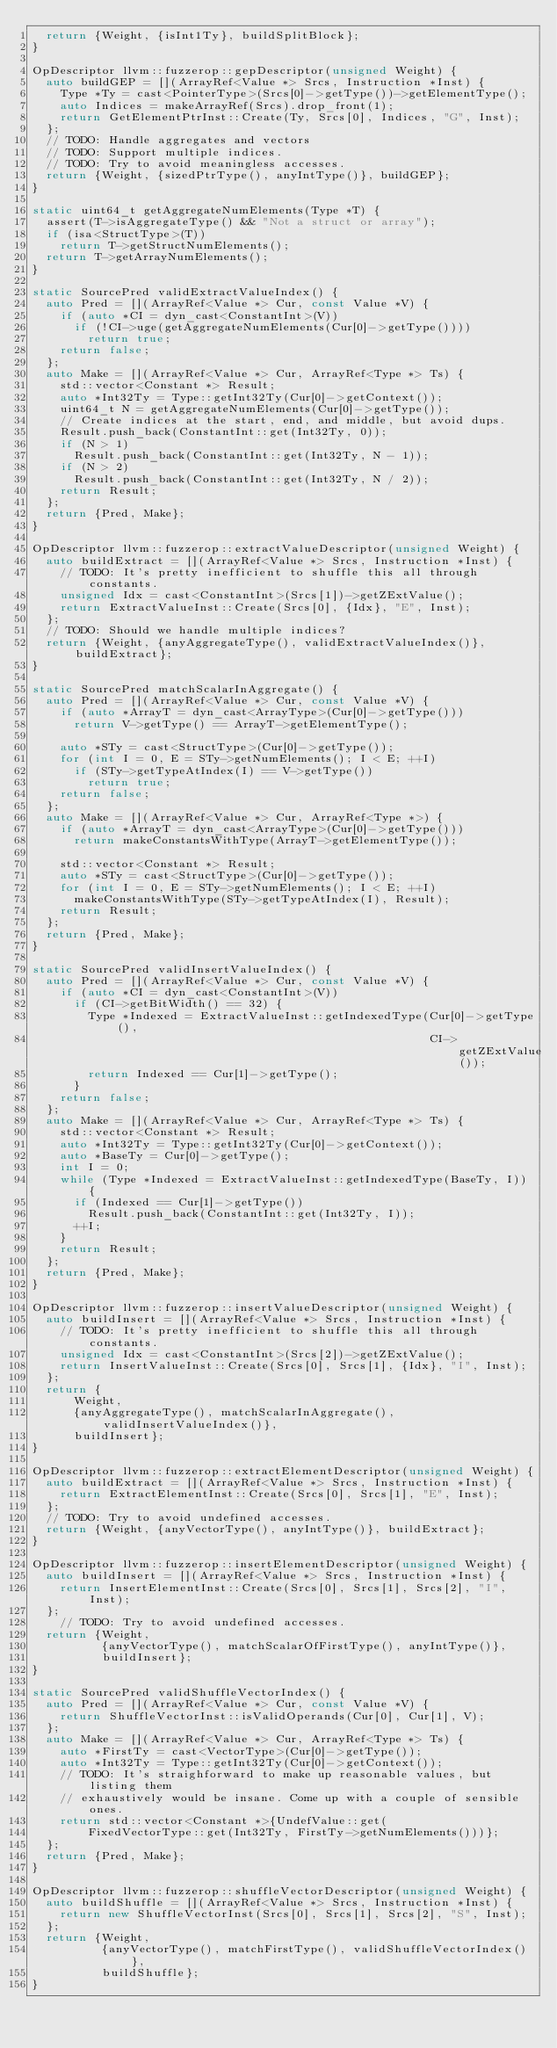Convert code to text. <code><loc_0><loc_0><loc_500><loc_500><_C++_>  return {Weight, {isInt1Ty}, buildSplitBlock};
}

OpDescriptor llvm::fuzzerop::gepDescriptor(unsigned Weight) {
  auto buildGEP = [](ArrayRef<Value *> Srcs, Instruction *Inst) {
    Type *Ty = cast<PointerType>(Srcs[0]->getType())->getElementType();
    auto Indices = makeArrayRef(Srcs).drop_front(1);
    return GetElementPtrInst::Create(Ty, Srcs[0], Indices, "G", Inst);
  };
  // TODO: Handle aggregates and vectors
  // TODO: Support multiple indices.
  // TODO: Try to avoid meaningless accesses.
  return {Weight, {sizedPtrType(), anyIntType()}, buildGEP};
}

static uint64_t getAggregateNumElements(Type *T) {
  assert(T->isAggregateType() && "Not a struct or array");
  if (isa<StructType>(T))
    return T->getStructNumElements();
  return T->getArrayNumElements();
}

static SourcePred validExtractValueIndex() {
  auto Pred = [](ArrayRef<Value *> Cur, const Value *V) {
    if (auto *CI = dyn_cast<ConstantInt>(V))
      if (!CI->uge(getAggregateNumElements(Cur[0]->getType())))
        return true;
    return false;
  };
  auto Make = [](ArrayRef<Value *> Cur, ArrayRef<Type *> Ts) {
    std::vector<Constant *> Result;
    auto *Int32Ty = Type::getInt32Ty(Cur[0]->getContext());
    uint64_t N = getAggregateNumElements(Cur[0]->getType());
    // Create indices at the start, end, and middle, but avoid dups.
    Result.push_back(ConstantInt::get(Int32Ty, 0));
    if (N > 1)
      Result.push_back(ConstantInt::get(Int32Ty, N - 1));
    if (N > 2)
      Result.push_back(ConstantInt::get(Int32Ty, N / 2));
    return Result;
  };
  return {Pred, Make};
}

OpDescriptor llvm::fuzzerop::extractValueDescriptor(unsigned Weight) {
  auto buildExtract = [](ArrayRef<Value *> Srcs, Instruction *Inst) {
    // TODO: It's pretty inefficient to shuffle this all through constants.
    unsigned Idx = cast<ConstantInt>(Srcs[1])->getZExtValue();
    return ExtractValueInst::Create(Srcs[0], {Idx}, "E", Inst);
  };
  // TODO: Should we handle multiple indices?
  return {Weight, {anyAggregateType(), validExtractValueIndex()}, buildExtract};
}

static SourcePred matchScalarInAggregate() {
  auto Pred = [](ArrayRef<Value *> Cur, const Value *V) {
    if (auto *ArrayT = dyn_cast<ArrayType>(Cur[0]->getType()))
      return V->getType() == ArrayT->getElementType();

    auto *STy = cast<StructType>(Cur[0]->getType());
    for (int I = 0, E = STy->getNumElements(); I < E; ++I)
      if (STy->getTypeAtIndex(I) == V->getType())
        return true;
    return false;
  };
  auto Make = [](ArrayRef<Value *> Cur, ArrayRef<Type *>) {
    if (auto *ArrayT = dyn_cast<ArrayType>(Cur[0]->getType()))
      return makeConstantsWithType(ArrayT->getElementType());

    std::vector<Constant *> Result;
    auto *STy = cast<StructType>(Cur[0]->getType());
    for (int I = 0, E = STy->getNumElements(); I < E; ++I)
      makeConstantsWithType(STy->getTypeAtIndex(I), Result);
    return Result;
  };
  return {Pred, Make};
}

static SourcePred validInsertValueIndex() {
  auto Pred = [](ArrayRef<Value *> Cur, const Value *V) {
    if (auto *CI = dyn_cast<ConstantInt>(V))
      if (CI->getBitWidth() == 32) {
        Type *Indexed = ExtractValueInst::getIndexedType(Cur[0]->getType(),
                                                         CI->getZExtValue());
        return Indexed == Cur[1]->getType();
      }
    return false;
  };
  auto Make = [](ArrayRef<Value *> Cur, ArrayRef<Type *> Ts) {
    std::vector<Constant *> Result;
    auto *Int32Ty = Type::getInt32Ty(Cur[0]->getContext());
    auto *BaseTy = Cur[0]->getType();
    int I = 0;
    while (Type *Indexed = ExtractValueInst::getIndexedType(BaseTy, I)) {
      if (Indexed == Cur[1]->getType())
        Result.push_back(ConstantInt::get(Int32Ty, I));
      ++I;
    }
    return Result;
  };
  return {Pred, Make};
}

OpDescriptor llvm::fuzzerop::insertValueDescriptor(unsigned Weight) {
  auto buildInsert = [](ArrayRef<Value *> Srcs, Instruction *Inst) {
    // TODO: It's pretty inefficient to shuffle this all through constants.
    unsigned Idx = cast<ConstantInt>(Srcs[2])->getZExtValue();
    return InsertValueInst::Create(Srcs[0], Srcs[1], {Idx}, "I", Inst);
  };
  return {
      Weight,
      {anyAggregateType(), matchScalarInAggregate(), validInsertValueIndex()},
      buildInsert};
}

OpDescriptor llvm::fuzzerop::extractElementDescriptor(unsigned Weight) {
  auto buildExtract = [](ArrayRef<Value *> Srcs, Instruction *Inst) {
    return ExtractElementInst::Create(Srcs[0], Srcs[1], "E", Inst);
  };
  // TODO: Try to avoid undefined accesses.
  return {Weight, {anyVectorType(), anyIntType()}, buildExtract};
}

OpDescriptor llvm::fuzzerop::insertElementDescriptor(unsigned Weight) {
  auto buildInsert = [](ArrayRef<Value *> Srcs, Instruction *Inst) {
    return InsertElementInst::Create(Srcs[0], Srcs[1], Srcs[2], "I", Inst);
  };
    // TODO: Try to avoid undefined accesses.
  return {Weight,
          {anyVectorType(), matchScalarOfFirstType(), anyIntType()},
          buildInsert};
}

static SourcePred validShuffleVectorIndex() {
  auto Pred = [](ArrayRef<Value *> Cur, const Value *V) {
    return ShuffleVectorInst::isValidOperands(Cur[0], Cur[1], V);
  };
  auto Make = [](ArrayRef<Value *> Cur, ArrayRef<Type *> Ts) {
    auto *FirstTy = cast<VectorType>(Cur[0]->getType());
    auto *Int32Ty = Type::getInt32Ty(Cur[0]->getContext());
    // TODO: It's straighforward to make up reasonable values, but listing them
    // exhaustively would be insane. Come up with a couple of sensible ones.
    return std::vector<Constant *>{UndefValue::get(
        FixedVectorType::get(Int32Ty, FirstTy->getNumElements()))};
  };
  return {Pred, Make};
}

OpDescriptor llvm::fuzzerop::shuffleVectorDescriptor(unsigned Weight) {
  auto buildShuffle = [](ArrayRef<Value *> Srcs, Instruction *Inst) {
    return new ShuffleVectorInst(Srcs[0], Srcs[1], Srcs[2], "S", Inst);
  };
  return {Weight,
          {anyVectorType(), matchFirstType(), validShuffleVectorIndex()},
          buildShuffle};
}
</code> 